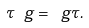<formula> <loc_0><loc_0><loc_500><loc_500>\tau \ g = \ g \tau .</formula> 